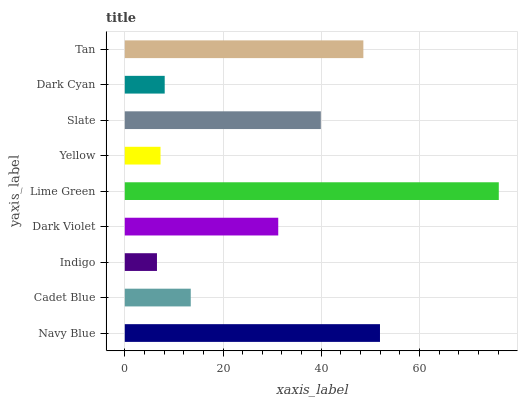Is Indigo the minimum?
Answer yes or no. Yes. Is Lime Green the maximum?
Answer yes or no. Yes. Is Cadet Blue the minimum?
Answer yes or no. No. Is Cadet Blue the maximum?
Answer yes or no. No. Is Navy Blue greater than Cadet Blue?
Answer yes or no. Yes. Is Cadet Blue less than Navy Blue?
Answer yes or no. Yes. Is Cadet Blue greater than Navy Blue?
Answer yes or no. No. Is Navy Blue less than Cadet Blue?
Answer yes or no. No. Is Dark Violet the high median?
Answer yes or no. Yes. Is Dark Violet the low median?
Answer yes or no. Yes. Is Yellow the high median?
Answer yes or no. No. Is Lime Green the low median?
Answer yes or no. No. 